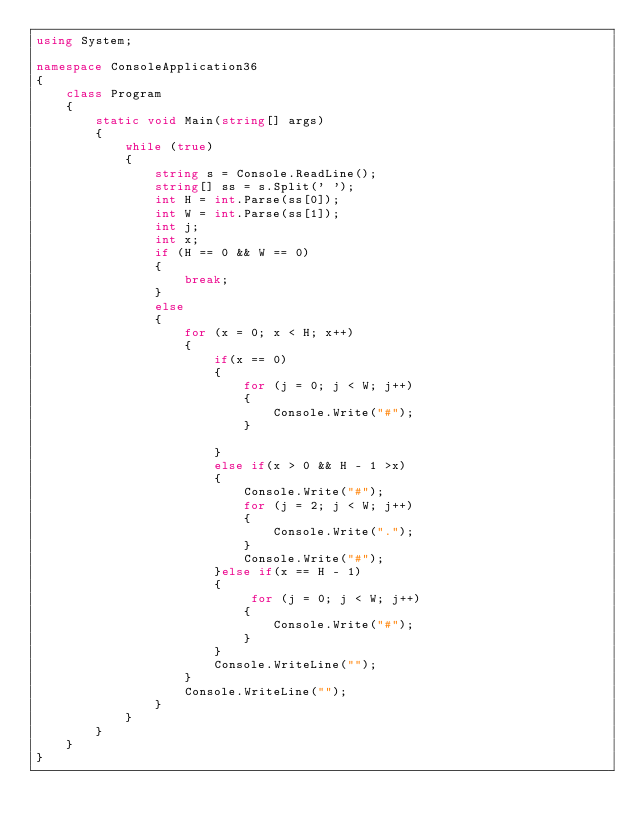<code> <loc_0><loc_0><loc_500><loc_500><_C#_>using System;

namespace ConsoleApplication36
{
    class Program
    {
        static void Main(string[] args)
        {
            while (true)
            {
                string s = Console.ReadLine();
                string[] ss = s.Split(' ');
                int H = int.Parse(ss[0]);
                int W = int.Parse(ss[1]);
                int j;
                int x;
                if (H == 0 && W == 0)
                {
                    break;
                }
                else
                {
                    for (x = 0; x < H; x++)
                    {
                        if(x == 0)
                        {
                            for (j = 0; j < W; j++)
                            {
                                Console.Write("#");
                            }

                        }
                        else if(x > 0 && H - 1 >x)
                        {
                            Console.Write("#");
                            for (j = 2; j < W; j++)
                            {
                                Console.Write(".");
                            }
                            Console.Write("#");
                        }else if(x == H - 1)
                        {
                             for (j = 0; j < W; j++)
                            {
                                Console.Write("#");
                            }
                        }
                        Console.WriteLine("");
                    }
                    Console.WriteLine("");
                }
            }
        }
    }
}</code> 